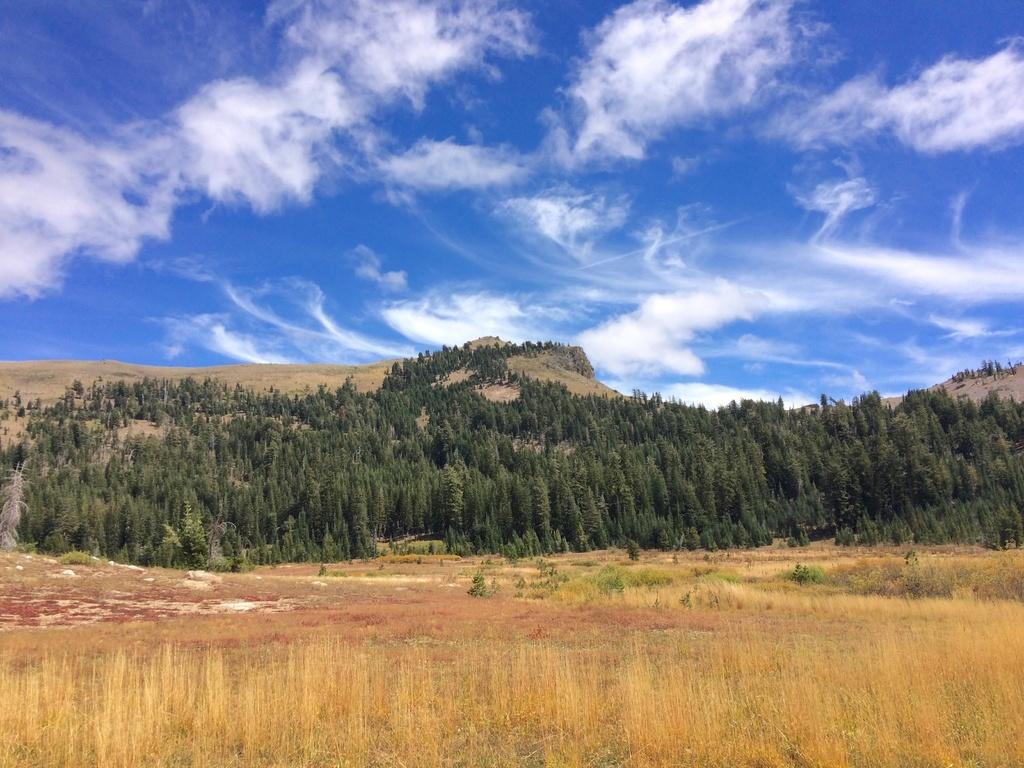What type of vegetation can be seen in the image? There is dried grass in brown color and trees in green color in the image. What can be seen in the background of the image? The sky is visible in the background of the image, and it is in blue and white color. How many beds can be seen in the image? There are no beds present in the image. What type of mouth is visible in the image? There is no mouth visible in the image. 